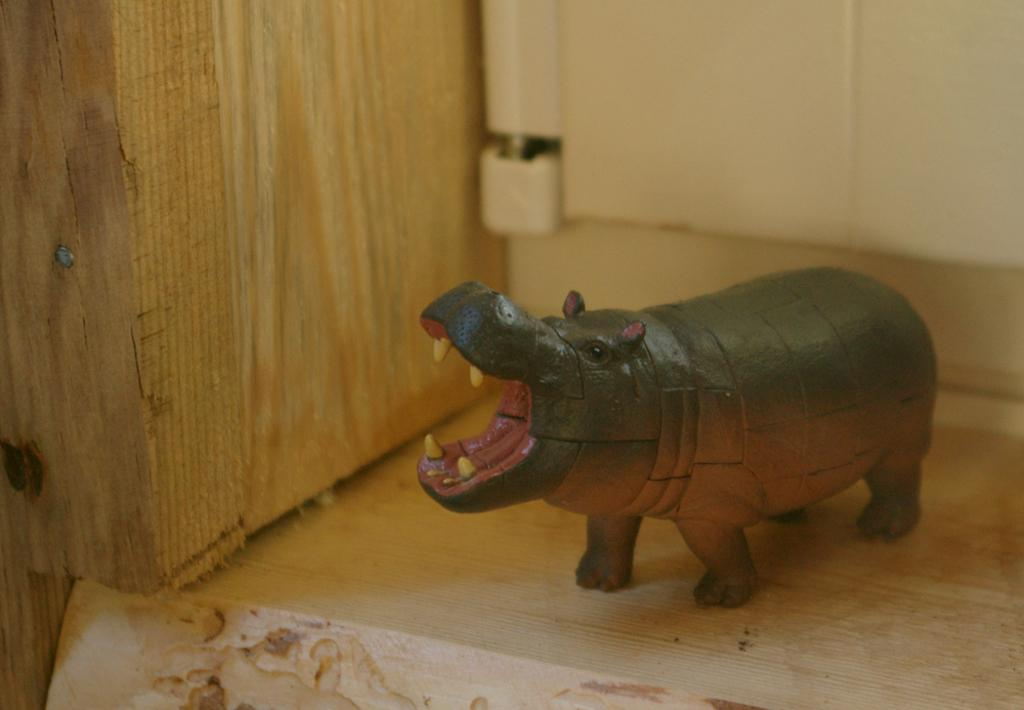What is the main subject of the image? There is a depiction of an animal on a wooden surface in the center of the image. What is the material of the surface where the animal is depicted? The surface is made of wood. What can be seen on the left side of the image? There is a wooden wall on the left side of the image. What type of soup is being served in the image? There is no soup present in the image; it features a depiction of an animal on a wooden surface and a wooden wall. 